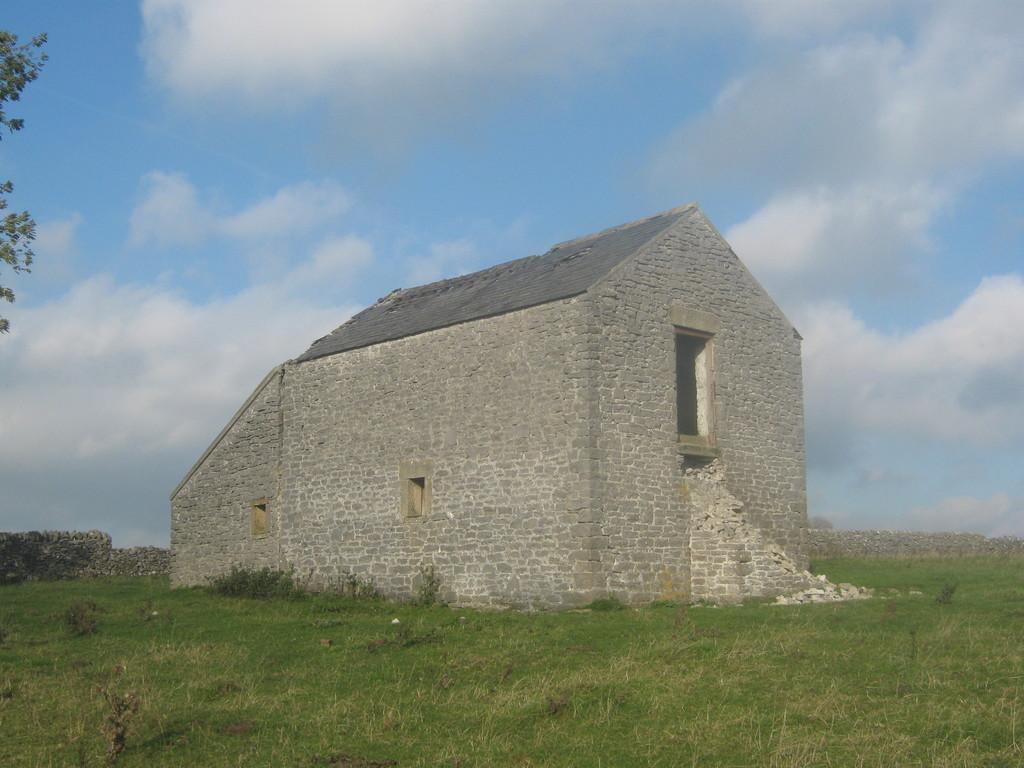What type of structure is visible in the picture? There is a house in the picture. How would you describe the sky in the image? The sky is blue and cloudy. Can you identify any vegetation in the picture? Yes, there is a tree on one side of the picture. What is the ground covered with in the image? Grass is present on the ground. What type of record is being played by the writer in the image? There is no record or writer present in the image. What appliance is being used by the person in the image? There is no person or appliance present in the image. 